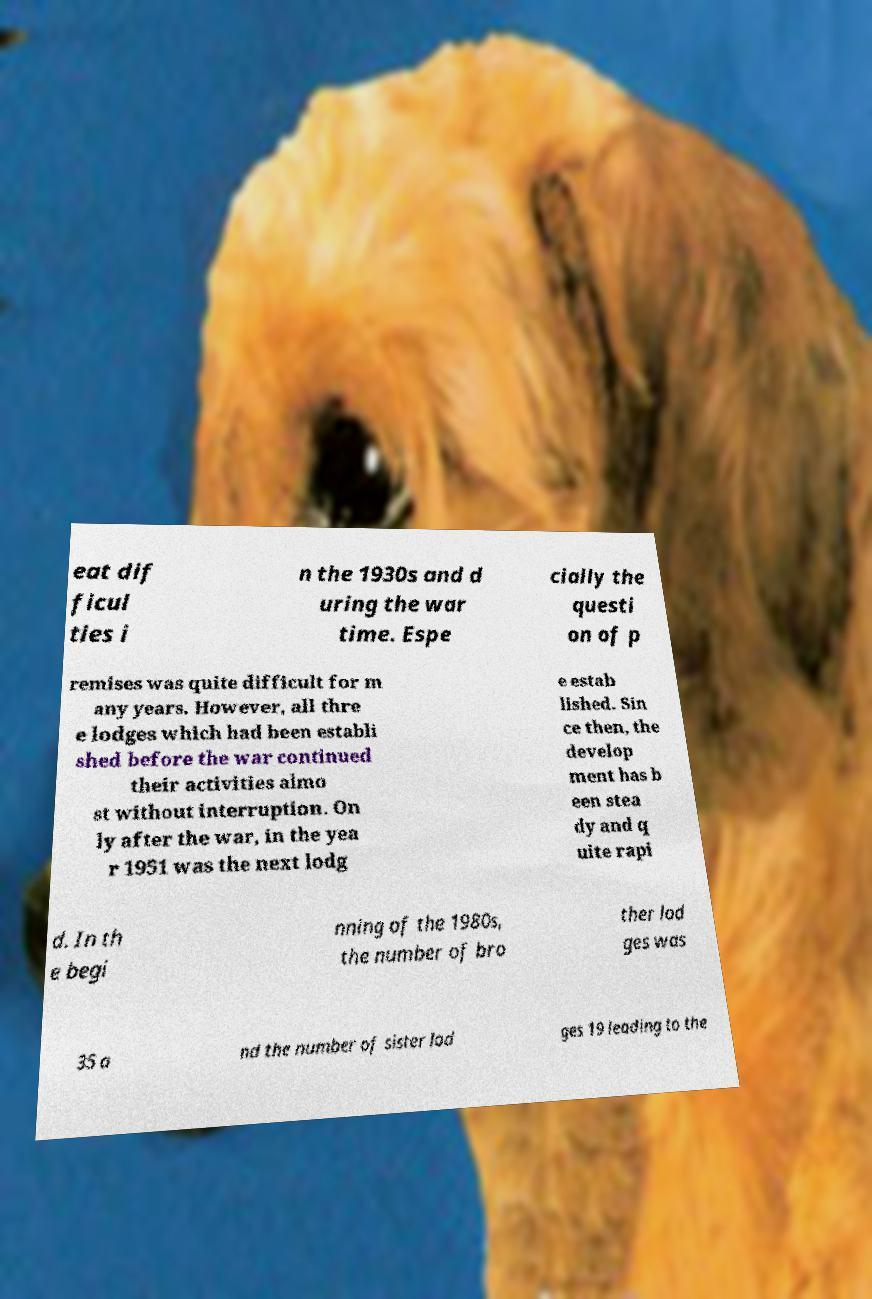Please identify and transcribe the text found in this image. eat dif ficul ties i n the 1930s and d uring the war time. Espe cially the questi on of p remises was quite difficult for m any years. However, all thre e lodges which had been establi shed before the war continued their activities almo st without interruption. On ly after the war, in the yea r 1951 was the next lodg e estab lished. Sin ce then, the develop ment has b een stea dy and q uite rapi d. In th e begi nning of the 1980s, the number of bro ther lod ges was 35 a nd the number of sister lod ges 19 leading to the 